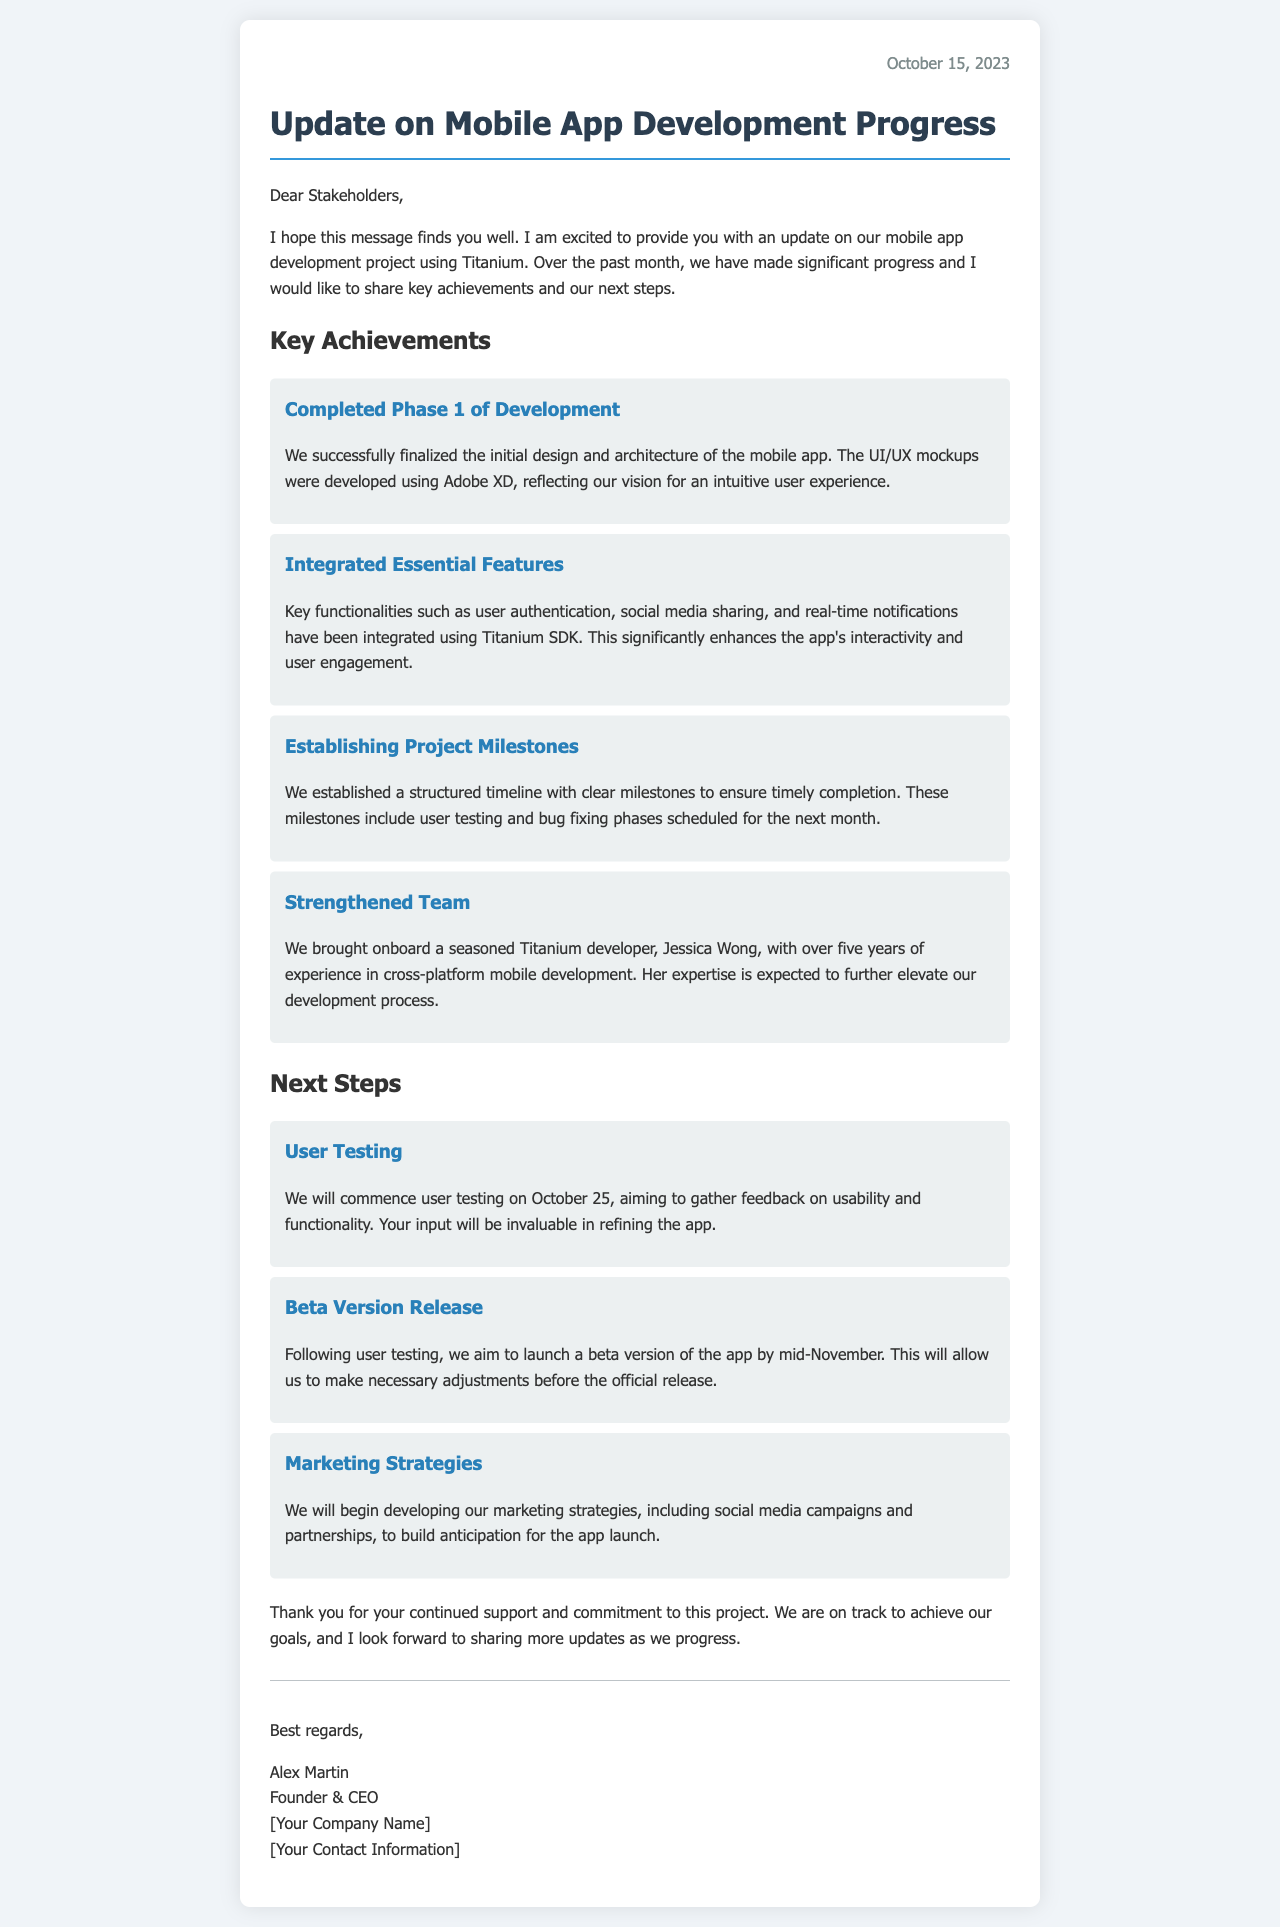What is the date of the update letter? The date is located in the top right corner of the document.
Answer: October 15, 2023 Who is the author of the letter? The author's name is found in the signature section of the document.
Answer: Alex Martin What phase of development has been completed? This information is stated in the section detailing key achievements.
Answer: Phase 1 of Development What feature has been integrated using Titanium SDK? The details of the integrated features are specified in the key achievements section.
Answer: User authentication When will user testing commence? The document specifies when user testing is scheduled to begin.
Answer: October 25 What will follow user testing? The text mentions the plan after user testing in the next steps section.
Answer: Beta Version Release How many years of experience does the new developer have? This information about the new team member's experience is included in the achievements section.
Answer: Five years What marketing strategies will be developed? The document outlines the next steps, indicating focus areas for the marketing efforts.
Answer: Social media campaigns and partnerships 